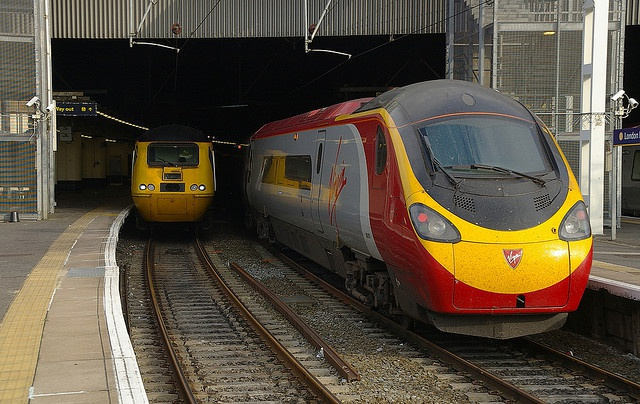Describe the objects in this image and their specific colors. I can see train in gray, black, maroon, and orange tones and train in gray, black, maroon, and olive tones in this image. 